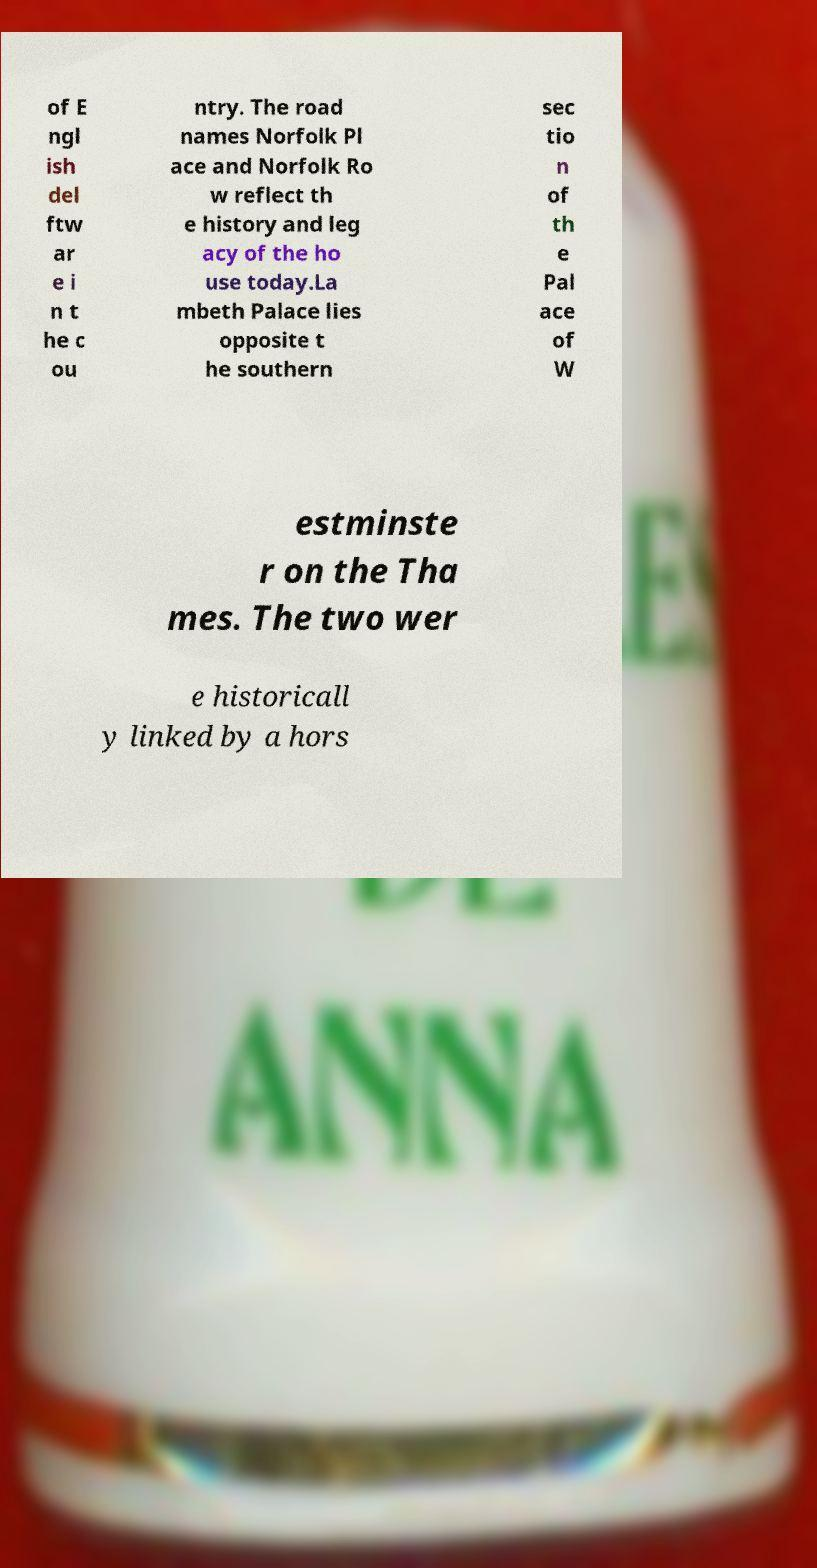There's text embedded in this image that I need extracted. Can you transcribe it verbatim? of E ngl ish del ftw ar e i n t he c ou ntry. The road names Norfolk Pl ace and Norfolk Ro w reflect th e history and leg acy of the ho use today.La mbeth Palace lies opposite t he southern sec tio n of th e Pal ace of W estminste r on the Tha mes. The two wer e historicall y linked by a hors 